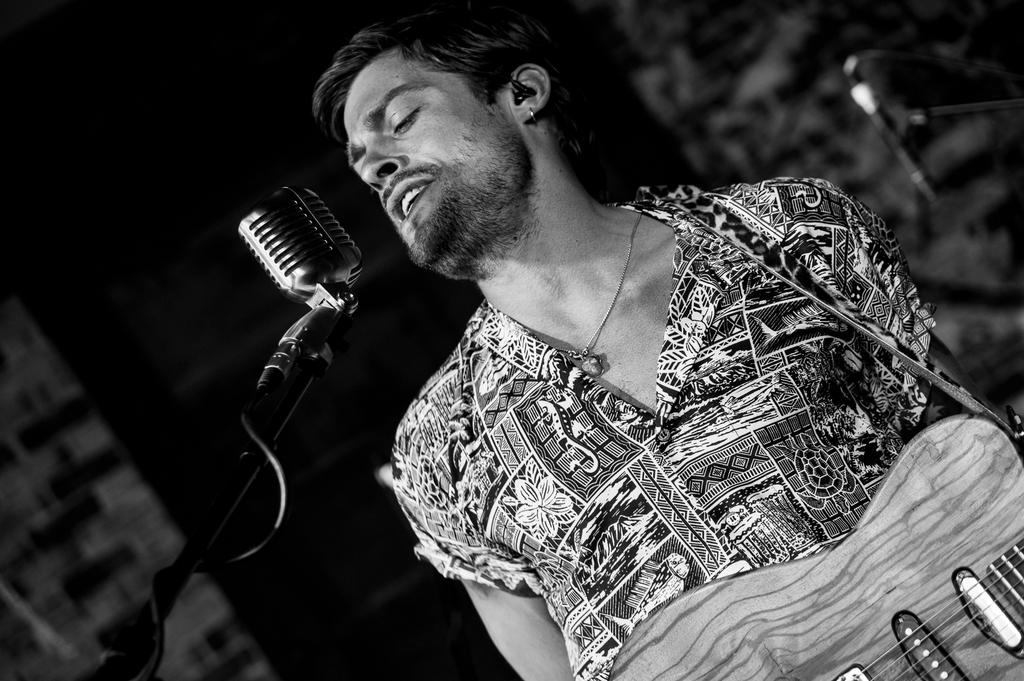What is the man in the image doing? The man is singing in the image. What is the man holding while singing? The man is holding a microphone and a guitar. What is the man wearing on his upper body? The man is wearing a shirt. How many elbows can be seen in the image? There is only one person in the image, so only one elbow can be seen. What message of peace is being conveyed in the image? There is no specific message of peace being conveyed in the image; it simply shows a man singing with a microphone and guitar. 